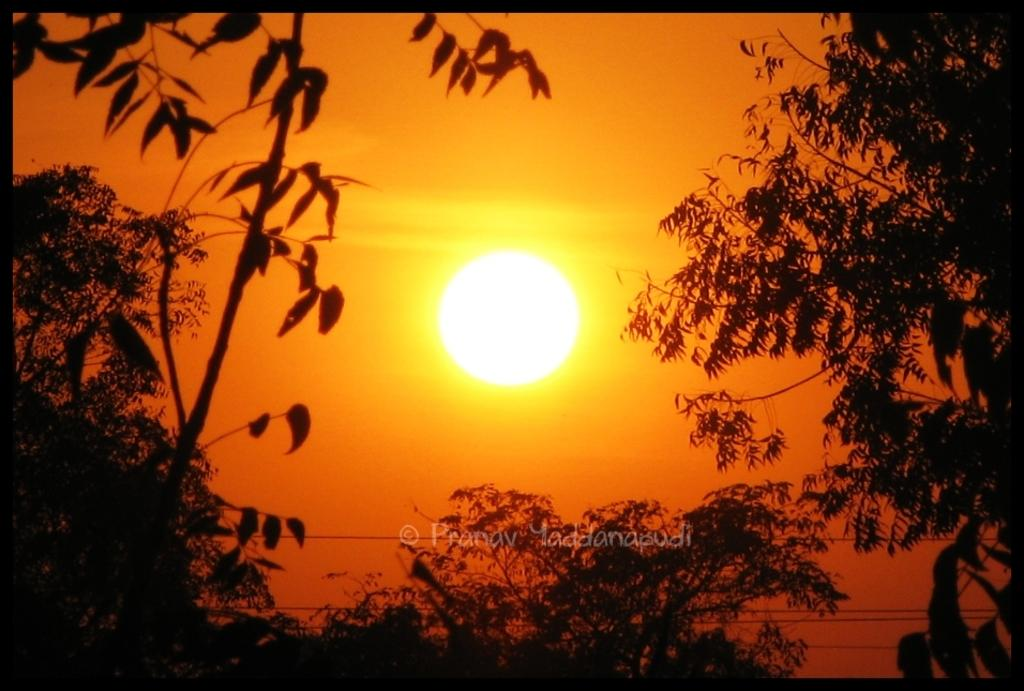What celestial body can be seen in the image? The sun is visible in the image. What type of vegetation is present in the image? There are trees in the image. Is there any indication of the image's origin or ownership? Yes, there is a watermark on the image. How many buckets of steam can be seen in the image? There are no buckets or steam present in the image. What day of the week is depicted in the image? The image does not depict a specific day of the week. 